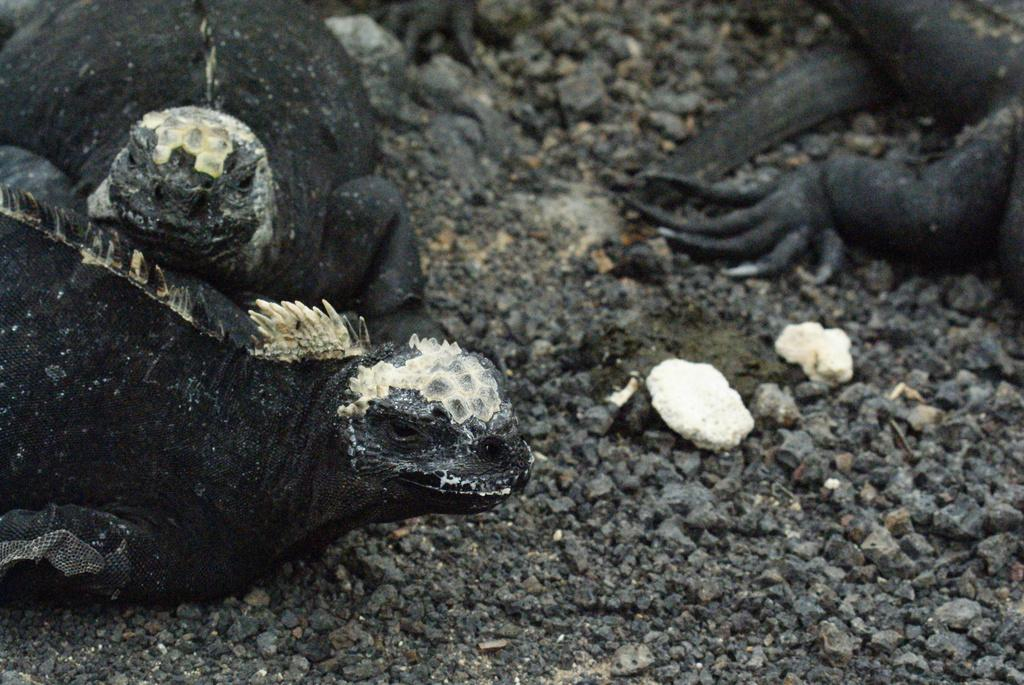What type of living organisms are present in the image? There are creatures in the image. What color are the creatures? The creatures are black in color. Where are the creatures located in the image? The creatures are on the ground. What letter is being harmonized by the creatures in the image? There is no letter or harmony present in the image; it features black creatures on the ground. Are the creatures wearing stockings in the image? There is no mention of stockings or any clothing on the creatures in the image. 